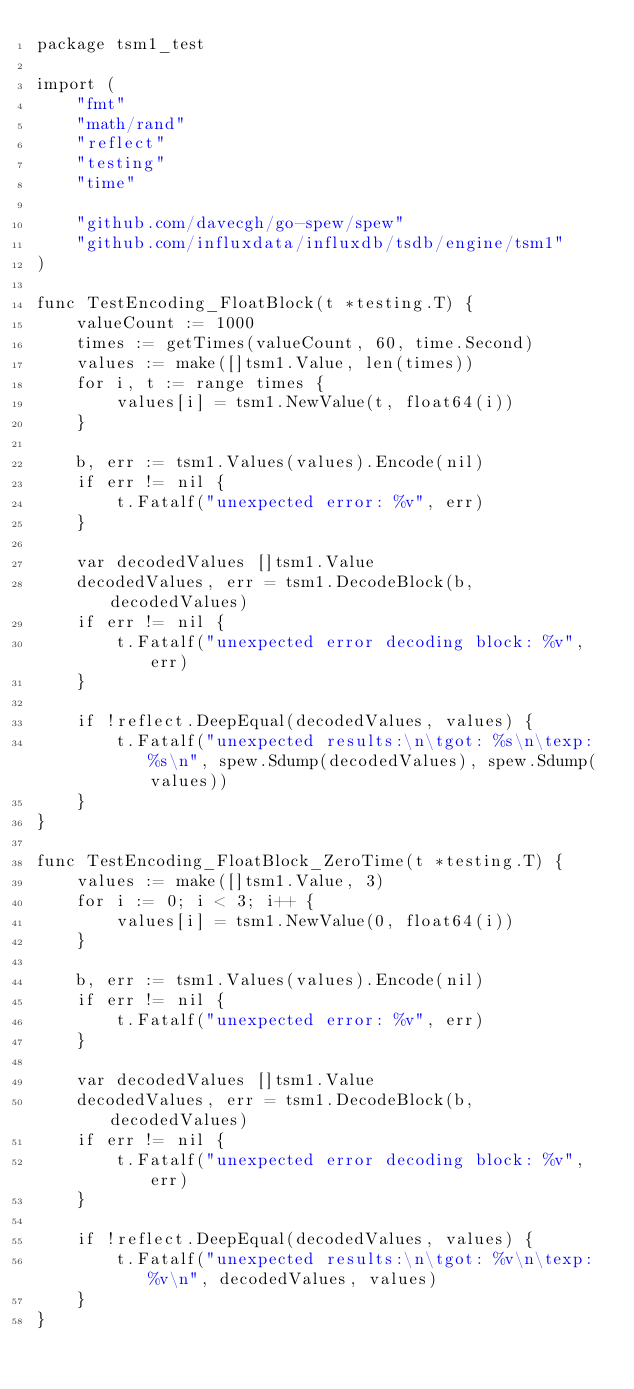Convert code to text. <code><loc_0><loc_0><loc_500><loc_500><_Go_>package tsm1_test

import (
	"fmt"
	"math/rand"
	"reflect"
	"testing"
	"time"

	"github.com/davecgh/go-spew/spew"
	"github.com/influxdata/influxdb/tsdb/engine/tsm1"
)

func TestEncoding_FloatBlock(t *testing.T) {
	valueCount := 1000
	times := getTimes(valueCount, 60, time.Second)
	values := make([]tsm1.Value, len(times))
	for i, t := range times {
		values[i] = tsm1.NewValue(t, float64(i))
	}

	b, err := tsm1.Values(values).Encode(nil)
	if err != nil {
		t.Fatalf("unexpected error: %v", err)
	}

	var decodedValues []tsm1.Value
	decodedValues, err = tsm1.DecodeBlock(b, decodedValues)
	if err != nil {
		t.Fatalf("unexpected error decoding block: %v", err)
	}

	if !reflect.DeepEqual(decodedValues, values) {
		t.Fatalf("unexpected results:\n\tgot: %s\n\texp: %s\n", spew.Sdump(decodedValues), spew.Sdump(values))
	}
}

func TestEncoding_FloatBlock_ZeroTime(t *testing.T) {
	values := make([]tsm1.Value, 3)
	for i := 0; i < 3; i++ {
		values[i] = tsm1.NewValue(0, float64(i))
	}

	b, err := tsm1.Values(values).Encode(nil)
	if err != nil {
		t.Fatalf("unexpected error: %v", err)
	}

	var decodedValues []tsm1.Value
	decodedValues, err = tsm1.DecodeBlock(b, decodedValues)
	if err != nil {
		t.Fatalf("unexpected error decoding block: %v", err)
	}

	if !reflect.DeepEqual(decodedValues, values) {
		t.Fatalf("unexpected results:\n\tgot: %v\n\texp: %v\n", decodedValues, values)
	}
}
</code> 